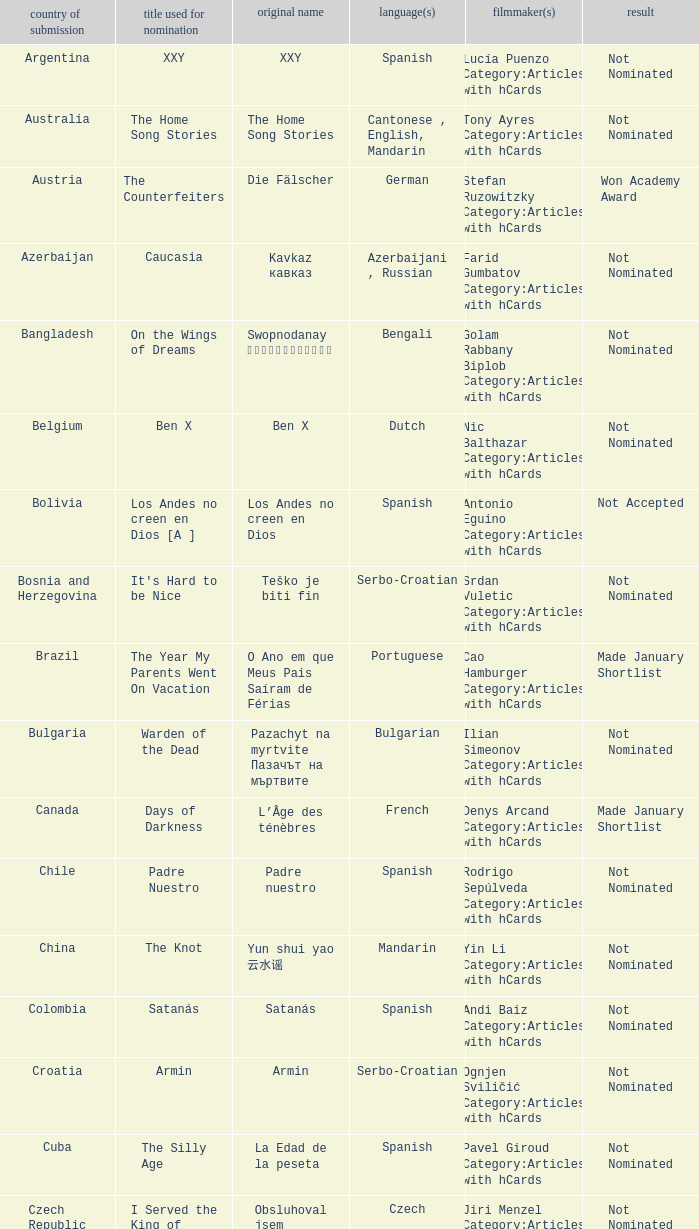What country submitted miehen työ? Finland. 